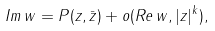Convert formula to latex. <formula><loc_0><loc_0><loc_500><loc_500>I m \, w = P ( z , \bar { z } ) + o ( R e \, w , | z | ^ { k } ) ,</formula> 